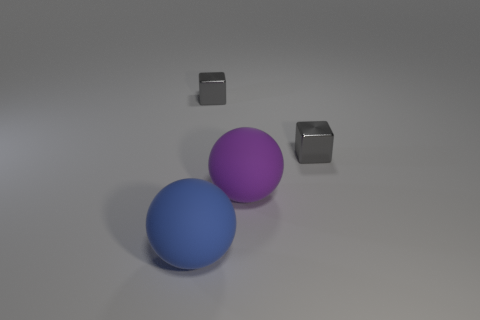There is a thing behind the small gray shiny object right of the large purple matte thing; how big is it?
Offer a terse response. Small. Does the big rubber object that is behind the large blue thing have the same shape as the big object in front of the large purple matte thing?
Keep it short and to the point. Yes. Are there an equal number of big blue objects in front of the big blue thing and tiny blue matte spheres?
Provide a short and direct response. Yes. What color is the other matte object that is the same shape as the purple object?
Provide a short and direct response. Blue. Are the big ball left of the purple matte object and the big purple sphere made of the same material?
Offer a very short reply. Yes. How many big things are either rubber objects or blocks?
Provide a short and direct response. 2. The purple matte sphere has what size?
Keep it short and to the point. Large. There is a purple sphere; does it have the same size as the rubber sphere left of the purple thing?
Your answer should be compact. Yes. How many gray things are large things or shiny cubes?
Make the answer very short. 2. How many gray metal objects are there?
Your answer should be compact. 2. 